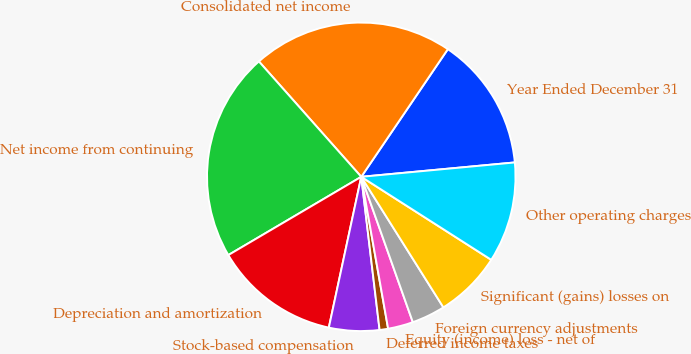<chart> <loc_0><loc_0><loc_500><loc_500><pie_chart><fcel>Year Ended December 31<fcel>Consolidated net income<fcel>Net income from continuing<fcel>Depreciation and amortization<fcel>Stock-based compensation<fcel>Deferred income taxes<fcel>Equity (income) loss - net of<fcel>Foreign currency adjustments<fcel>Significant (gains) losses on<fcel>Other operating charges<nl><fcel>14.03%<fcel>21.04%<fcel>21.92%<fcel>13.16%<fcel>5.27%<fcel>0.89%<fcel>2.64%<fcel>3.51%<fcel>7.02%<fcel>10.53%<nl></chart> 